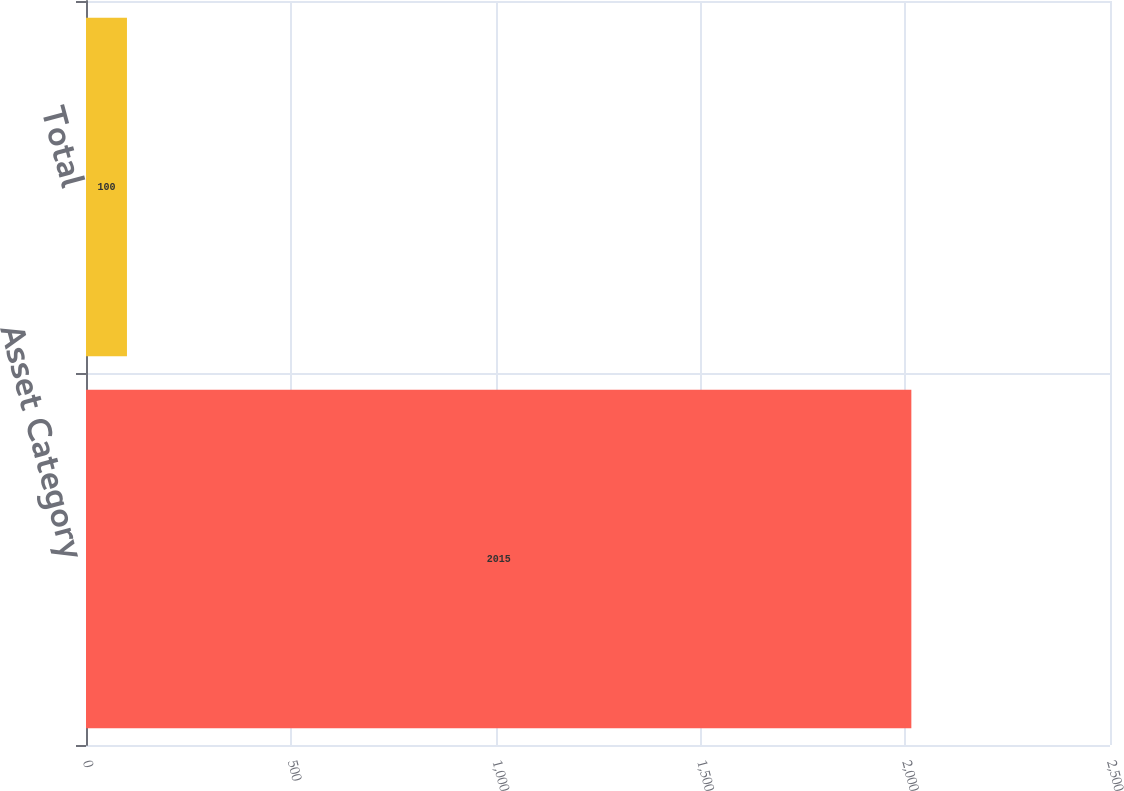<chart> <loc_0><loc_0><loc_500><loc_500><bar_chart><fcel>Asset Category<fcel>Total<nl><fcel>2015<fcel>100<nl></chart> 